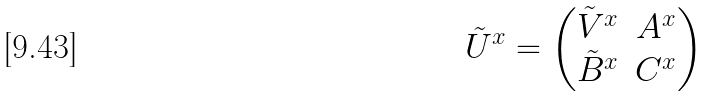<formula> <loc_0><loc_0><loc_500><loc_500>\tilde { U } ^ { x } = \begin{pmatrix} \tilde { V } ^ { x } & A ^ { x } \\ \tilde { B } ^ { x } & C ^ { x } \end{pmatrix}</formula> 